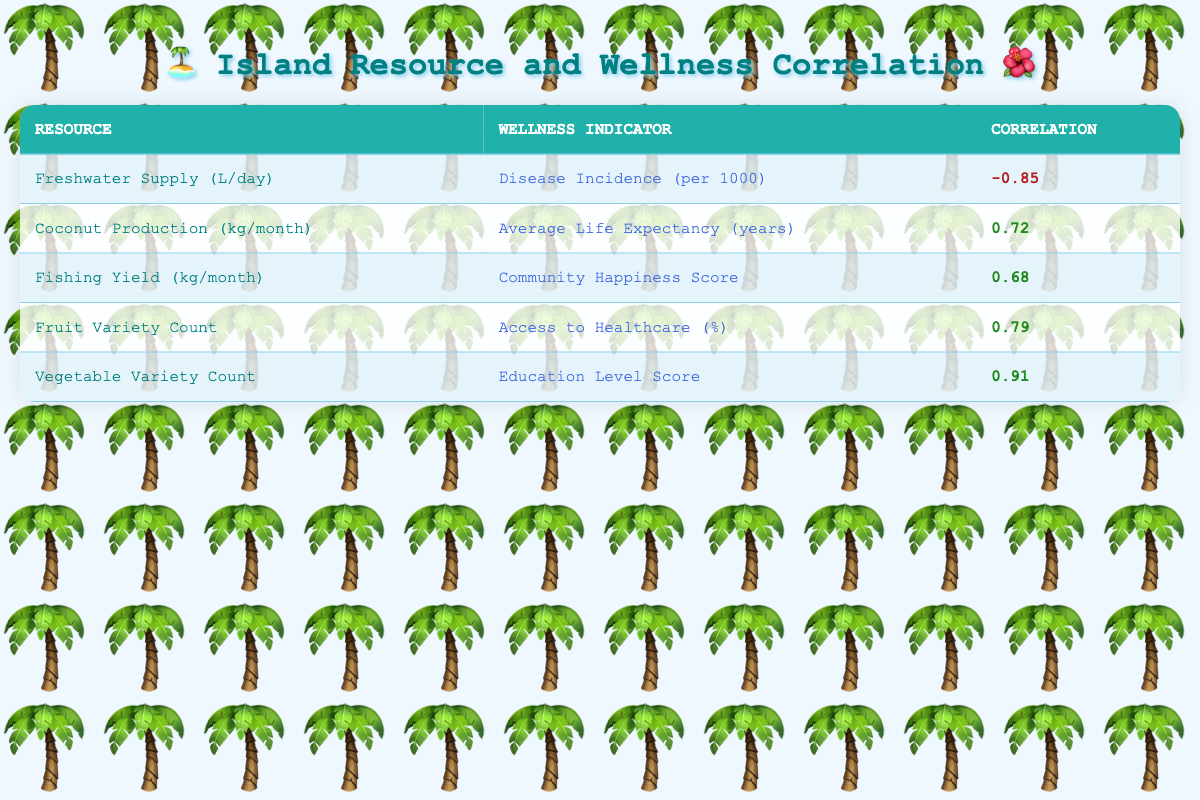What is the correlation between freshwater supply and disease incidence? The table shows a correlation value of -0.85 between freshwater supply and disease incidence per 1000. This indicates a strong negative correlation, suggesting that as the freshwater supply increases, the disease incidence decreases.
Answer: -0.85 How many wellness indicators have a positive correlation with vegetable variety count? From the table, we see that vegetable variety count is correlated positively with the education level score (0.91). Thus, there is one wellness indicator that has a positive correlation.
Answer: 1 What is the highest positive correlation value among the resource and wellness indicators? Looking through the table, the highest correlation value is 0.91, which relates vegetable variety count and education level score. Therefore, this is the highest positive correlation.
Answer: 0.91 If the average life expectancy increases, how many fewer cases of disease incidence might we expect per 1000? From the table, the average life expectancy is positively correlated with coconut production (0.72) and the disease incidence is negatively correlated with freshwater supply (-0.85). This does indicate a general trend that improving resources might lead to fewer disease cases; however, exact values cannot be directly calculated here without additional context or data. Therefore, we cannot provide an exact number.
Answer: Cannot determine exact number Is it true that higher coconut production corresponds to improved community happiness? The correlation between coconut production and average life expectancy is 0.72. However, the table does not explicitly provide a correlation between coconut production and community happiness; thus, we cannot confirm this as true based on the given data.
Answer: No, it’s not true 